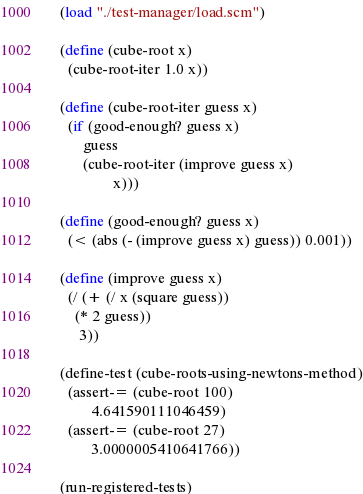<code> <loc_0><loc_0><loc_500><loc_500><_Scheme_>(load "./test-manager/load.scm")

(define (cube-root x)
  (cube-root-iter 1.0 x))

(define (cube-root-iter guess x)
  (if (good-enough? guess x)
      guess
      (cube-root-iter (improve guess x)
		      x)))

(define (good-enough? guess x)
  (< (abs (- (improve guess x) guess)) 0.001))

(define (improve guess x)
  (/ (+ (/ x (square guess))
	(* 2 guess))
     3))

(define-test (cube-roots-using-newtons-method)
  (assert-= (cube-root 100)
	    4.641590111046459)
  (assert-= (cube-root 27)
	    3.0000005410641766))

(run-registered-tests)</code> 